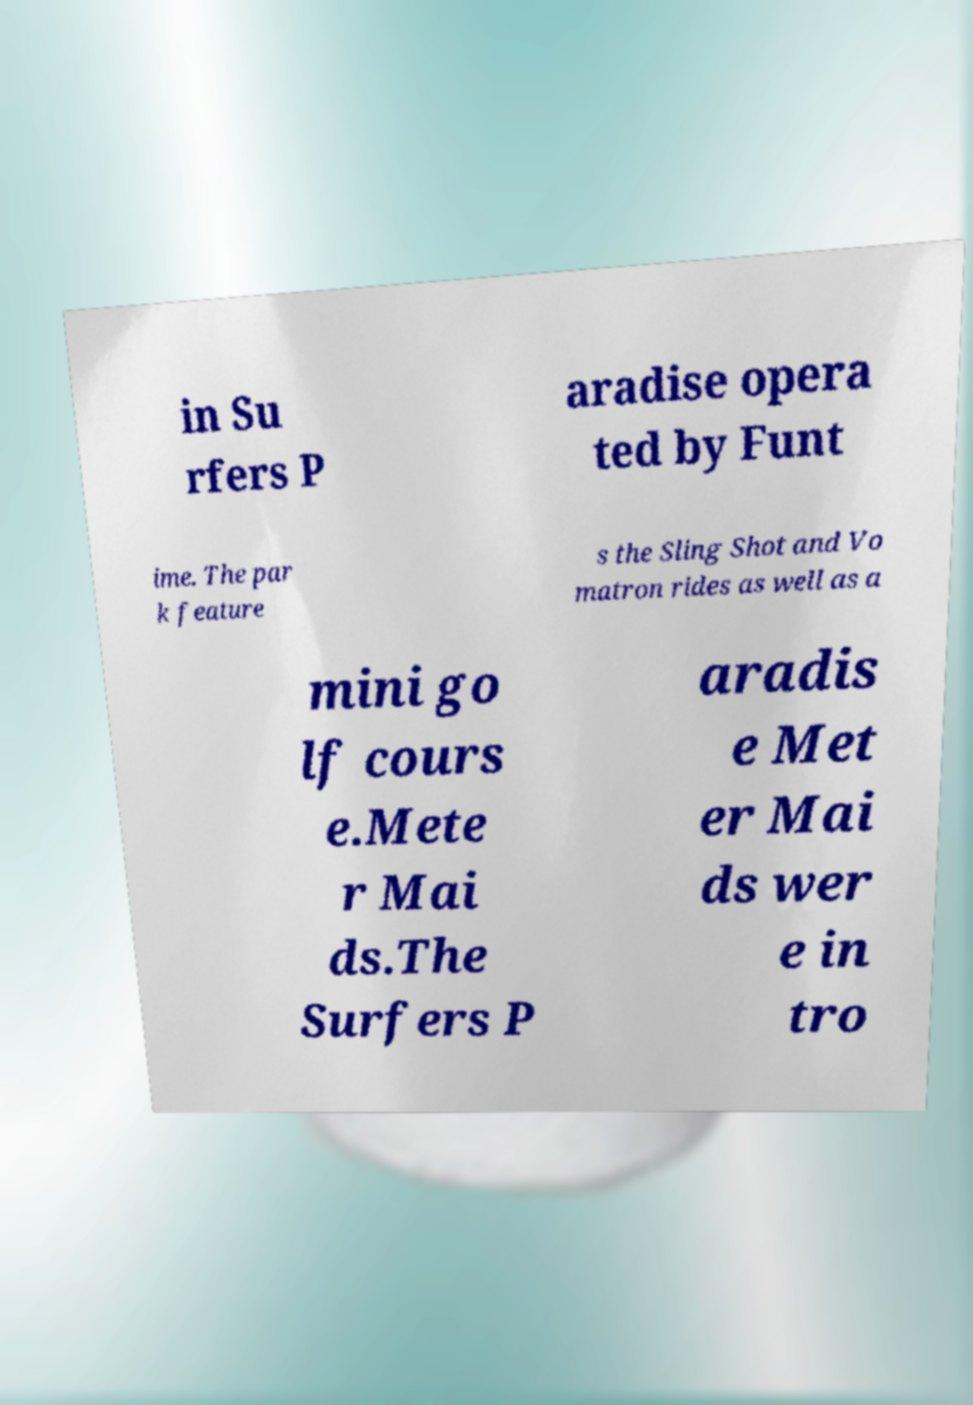What messages or text are displayed in this image? I need them in a readable, typed format. in Su rfers P aradise opera ted by Funt ime. The par k feature s the Sling Shot and Vo matron rides as well as a mini go lf cours e.Mete r Mai ds.The Surfers P aradis e Met er Mai ds wer e in tro 